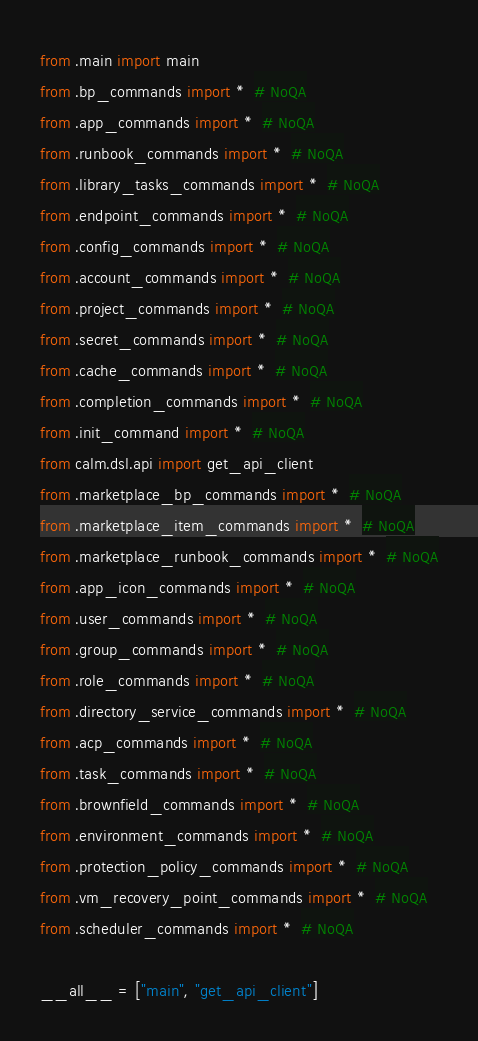<code> <loc_0><loc_0><loc_500><loc_500><_Python_>from .main import main
from .bp_commands import *  # NoQA
from .app_commands import *  # NoQA
from .runbook_commands import *  # NoQA
from .library_tasks_commands import *  # NoQA
from .endpoint_commands import *  # NoQA
from .config_commands import *  # NoQA
from .account_commands import *  # NoQA
from .project_commands import *  # NoQA
from .secret_commands import *  # NoQA
from .cache_commands import *  # NoQA
from .completion_commands import *  # NoQA
from .init_command import *  # NoQA
from calm.dsl.api import get_api_client
from .marketplace_bp_commands import *  # NoQA
from .marketplace_item_commands import *  # NoQA
from .marketplace_runbook_commands import *  # NoQA
from .app_icon_commands import *  # NoQA
from .user_commands import *  # NoQA
from .group_commands import *  # NoQA
from .role_commands import *  # NoQA
from .directory_service_commands import *  # NoQA
from .acp_commands import *  # NoQA
from .task_commands import *  # NoQA
from .brownfield_commands import *  # NoQA
from .environment_commands import *  # NoQA
from .protection_policy_commands import *  # NoQA
from .vm_recovery_point_commands import *  # NoQA
from .scheduler_commands import *  # NoQA

__all__ = ["main", "get_api_client"]
</code> 